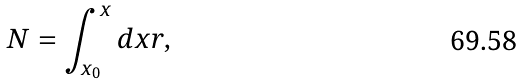Convert formula to latex. <formula><loc_0><loc_0><loc_500><loc_500>N = \int _ { x _ { 0 } } ^ { x } d x r \text {,}</formula> 